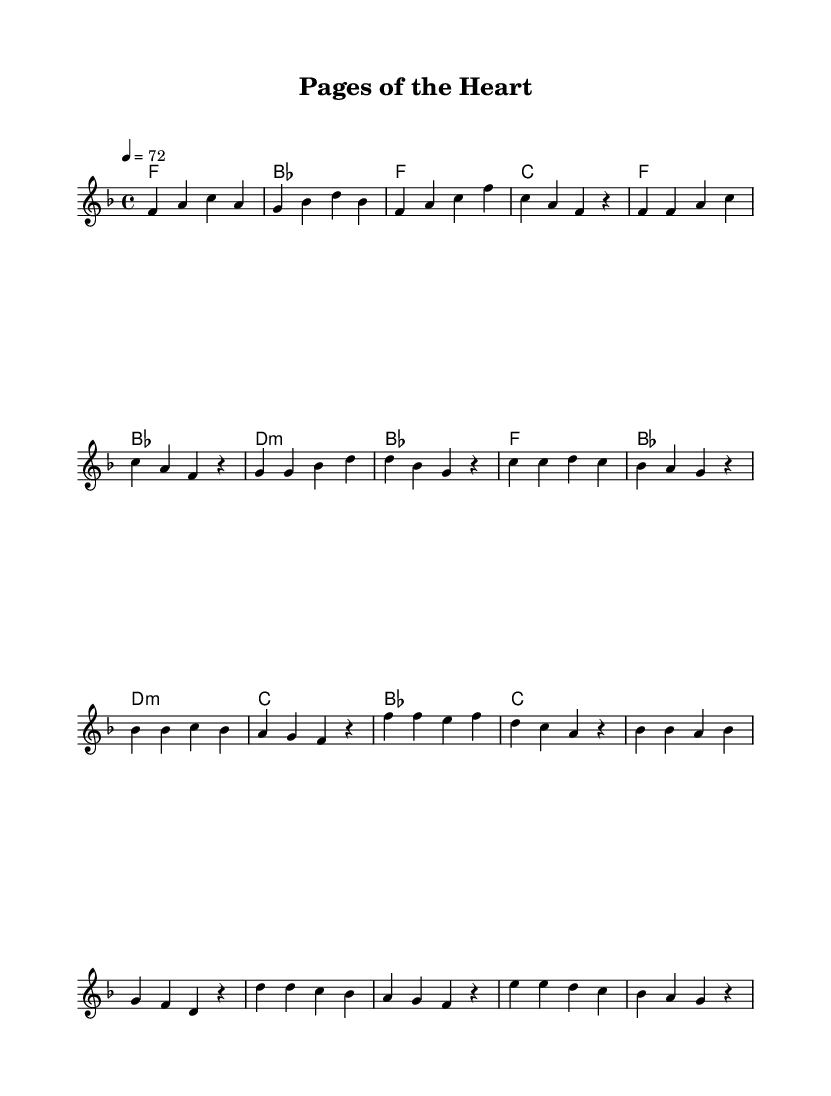What is the key signature of this music? The key signature is F major, which contains one flat (B flat). This is indicated at the beginning of the sheet music after the clef.
Answer: F major What is the time signature of this composition? The time signature is 4/4, which means there are four beats in each measure and a quarter note receives one beat. This can be found at the start of the piece, just like the key signature.
Answer: 4/4 What is the tempo marking for this piece? The tempo marking is 72 beats per minute, indicated at the beginning after the time signature. This indicates the speed at which the piece should be played.
Answer: 72 How many measures are in the chorus section? The chorus section consists of four measures, which can be counted by locating the section labeled 'Chorus' and counting the measures.
Answer: Four Which chord is played during the pre-chorus? The pre-chorus begins with a D minor chord and is followed by a B flat chord, as seen in the harmonies written above the melody.
Answer: D minor What type of music composition structure is primarily used in K-Pop, as seen in this piece? This piece reflects a verse-chorus structure, which is common in K-Pop, featuring distinct sections for verses, a pre-chorus, and a chorus. The arrangement matches the overall format typical of K-Pop songs.
Answer: Verse-chorus How is the emotional tone of the bridge section expressed in this piece? The bridge section has a more subdued emotional tone, utilizing softer notes and perhaps a change in dynamics. It connects the chorus and the following material emotionally, often transitioning in K-Pop to create a dramatic effect.
Answer: Subdued 